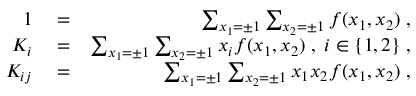<formula> <loc_0><loc_0><loc_500><loc_500>\begin{array} { r l r } { 1 } & = } & { \sum _ { x _ { 1 } = \pm 1 } \sum _ { x _ { 2 } = \pm 1 } f ( x _ { 1 } , x _ { 2 } ) \, , } \\ { K _ { i } } & = } & { \sum _ { x _ { 1 } = \pm 1 } \sum _ { x _ { 2 } = \pm 1 } x _ { i } f ( x _ { 1 } , x _ { 2 } ) \, , \, i \in \{ 1 , 2 \} \, , } \\ { K _ { i j } } & = } & { \sum _ { x _ { 1 } = \pm 1 } \sum _ { x _ { 2 } = \pm 1 } x _ { 1 } x _ { 2 } f ( x _ { 1 } , x _ { 2 } ) \, , } \end{array}</formula> 